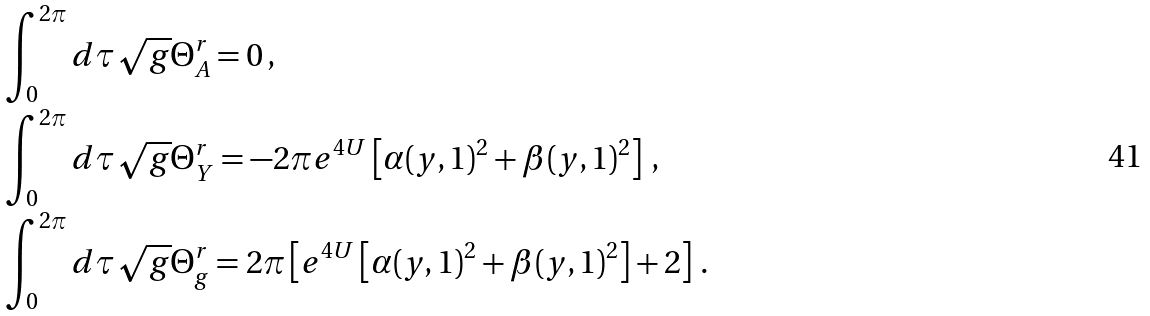<formula> <loc_0><loc_0><loc_500><loc_500>& \int ^ { 2 \pi } _ { 0 } d \tau \sqrt { g } \Theta ^ { r } _ { A } = 0 \, , \\ & \int ^ { 2 \pi } _ { 0 } d \tau \sqrt { g } \Theta ^ { r } _ { Y } = - 2 \pi e ^ { 4 U } \left [ \alpha ( y , 1 ) ^ { 2 } + \beta ( y , 1 ) ^ { 2 } \right ] \, , \\ & \int ^ { 2 \pi } _ { 0 } d \tau \sqrt { g } \Theta ^ { r } _ { g } = 2 \pi \left [ e ^ { 4 U } \left [ \alpha ( y , 1 ) ^ { 2 } + \beta ( y , 1 ) ^ { 2 } \right ] + 2 \right ] \, .</formula> 